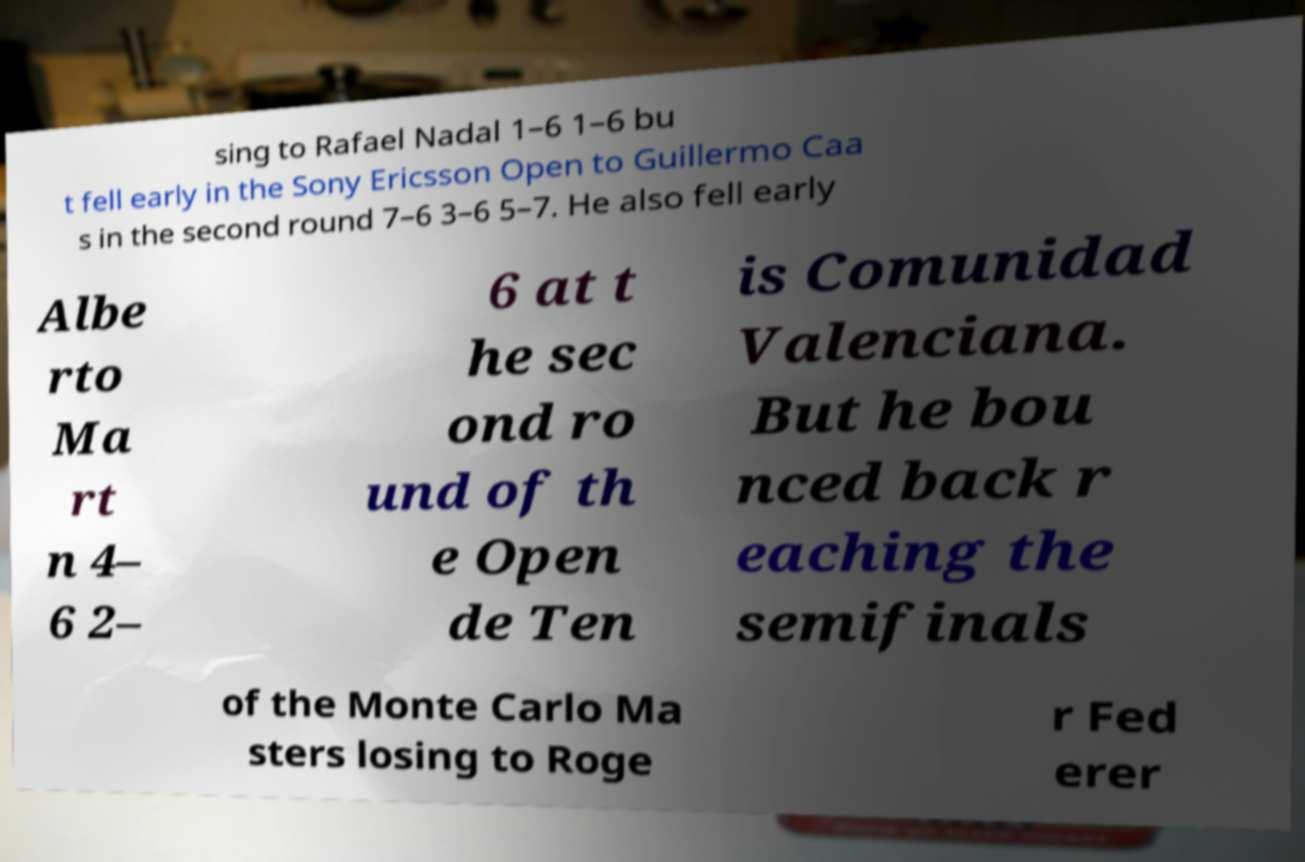I need the written content from this picture converted into text. Can you do that? sing to Rafael Nadal 1–6 1–6 bu t fell early in the Sony Ericsson Open to Guillermo Caa s in the second round 7–6 3–6 5–7. He also fell early Albe rto Ma rt n 4– 6 2– 6 at t he sec ond ro und of th e Open de Ten is Comunidad Valenciana. But he bou nced back r eaching the semifinals of the Monte Carlo Ma sters losing to Roge r Fed erer 